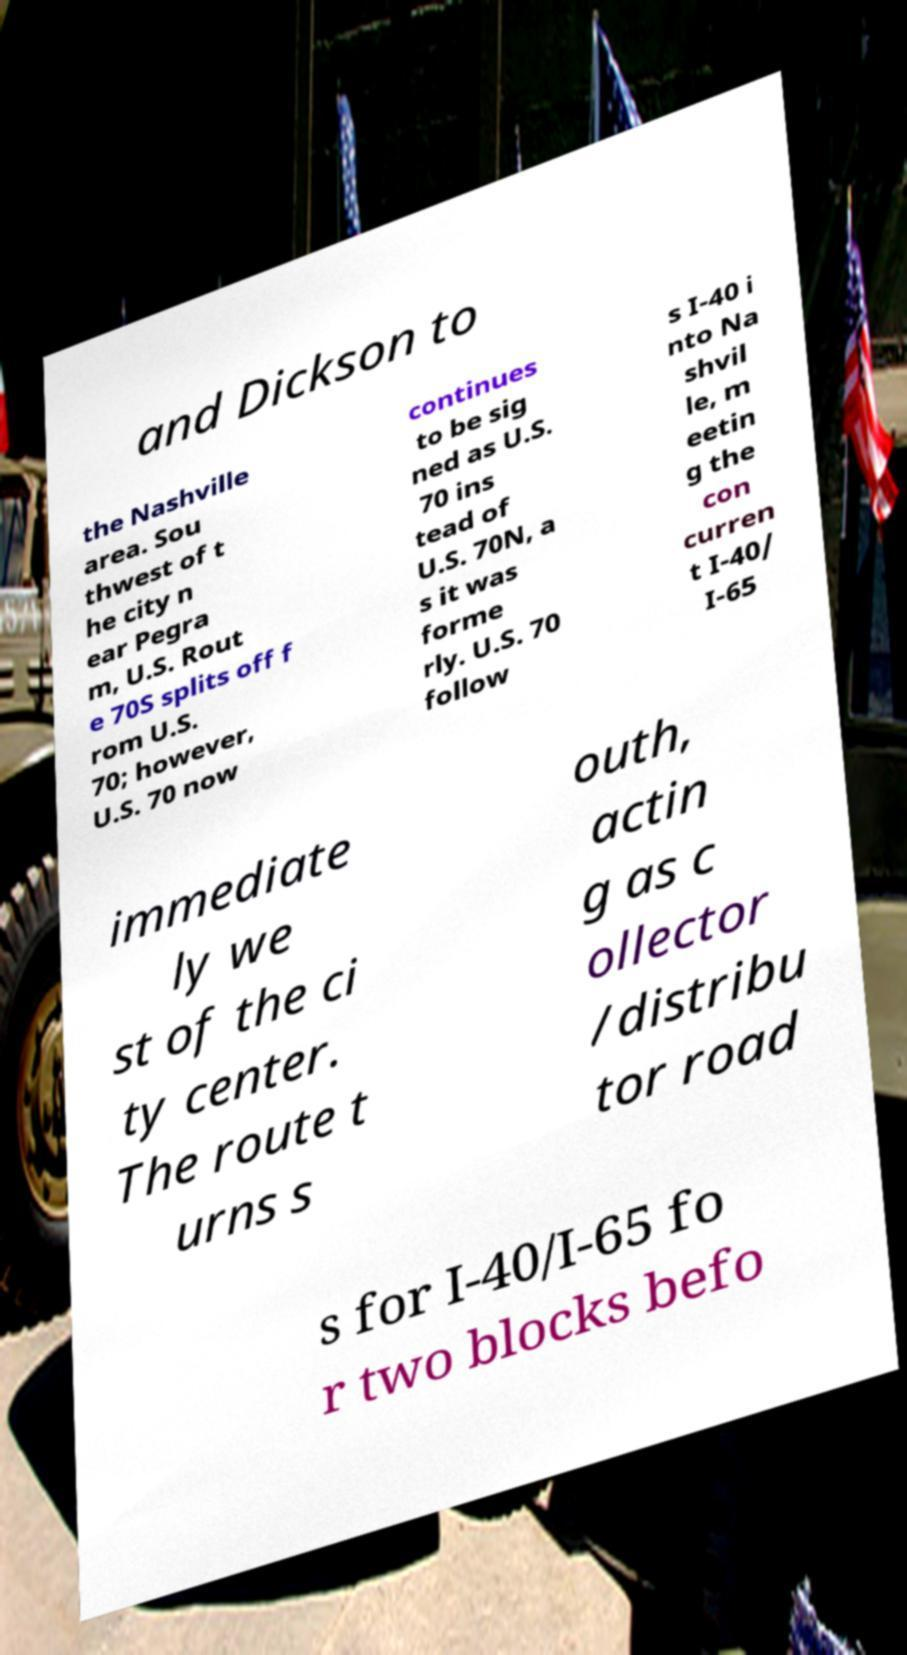Can you accurately transcribe the text from the provided image for me? and Dickson to the Nashville area. Sou thwest of t he city n ear Pegra m, U.S. Rout e 70S splits off f rom U.S. 70; however, U.S. 70 now continues to be sig ned as U.S. 70 ins tead of U.S. 70N, a s it was forme rly. U.S. 70 follow s I-40 i nto Na shvil le, m eetin g the con curren t I-40/ I-65 immediate ly we st of the ci ty center. The route t urns s outh, actin g as c ollector /distribu tor road s for I-40/I-65 fo r two blocks befo 